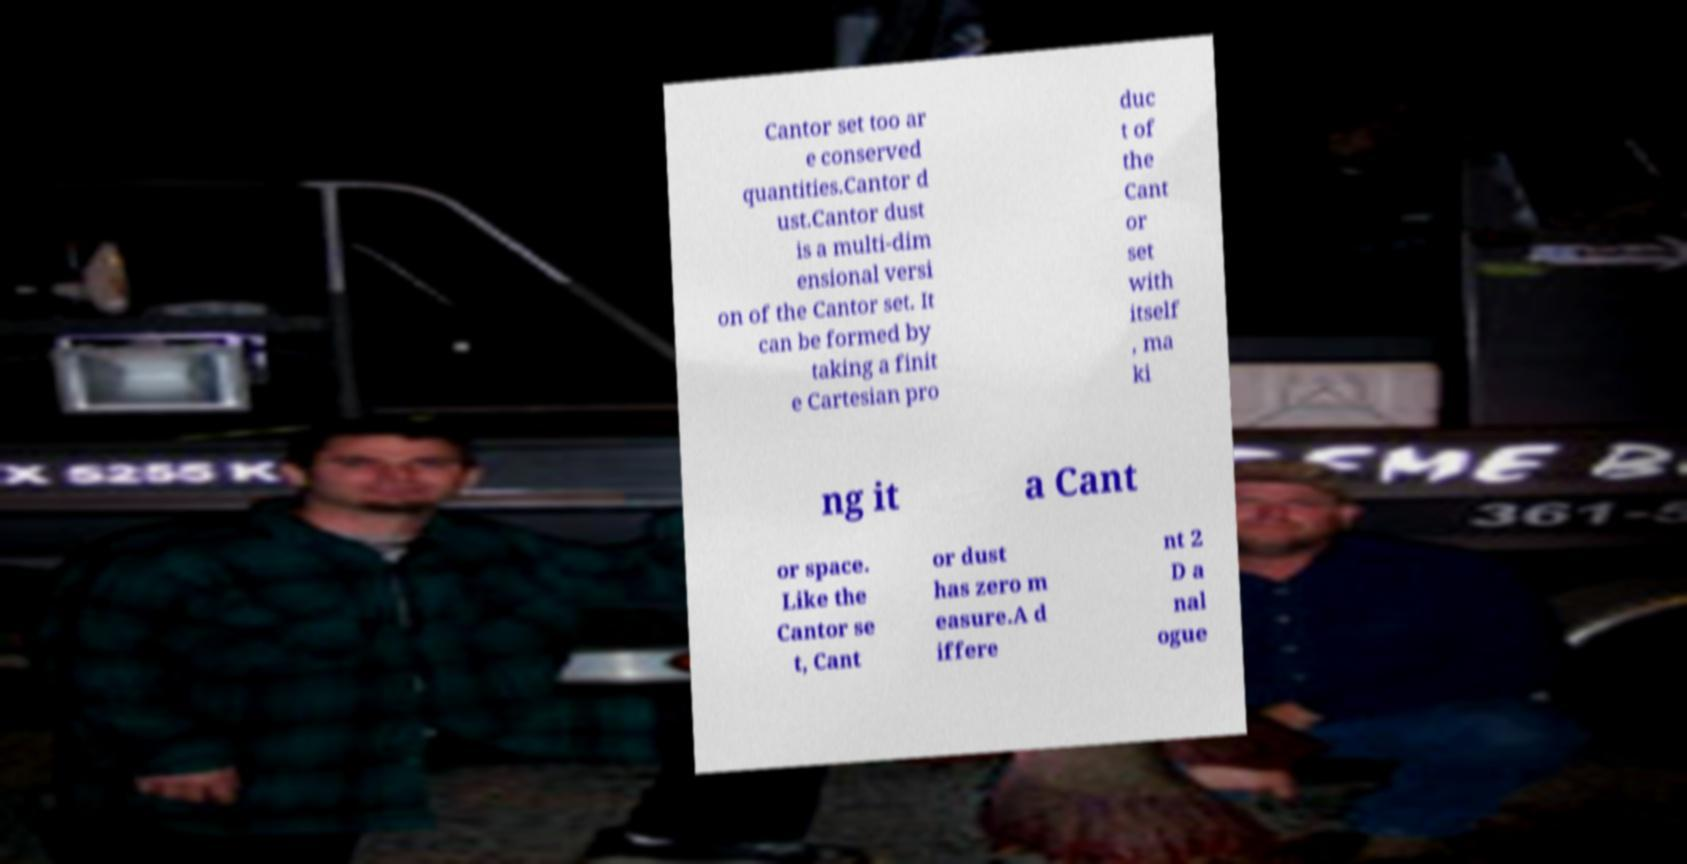Please read and relay the text visible in this image. What does it say? Cantor set too ar e conserved quantities.Cantor d ust.Cantor dust is a multi-dim ensional versi on of the Cantor set. It can be formed by taking a finit e Cartesian pro duc t of the Cant or set with itself , ma ki ng it a Cant or space. Like the Cantor se t, Cant or dust has zero m easure.A d iffere nt 2 D a nal ogue 